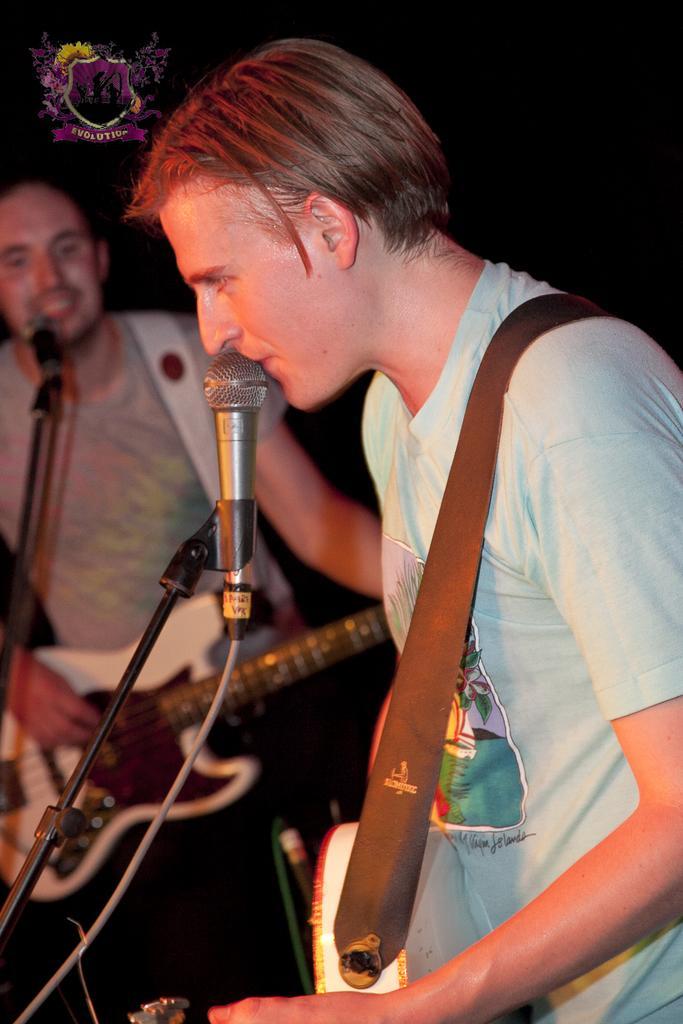Could you give a brief overview of what you see in this image? In the picture we can see a man holding a guitar and singing a song in the microphone, next to the man we can see another man holding a guitar near the microphone. The two men are wearing a T-shirts. 